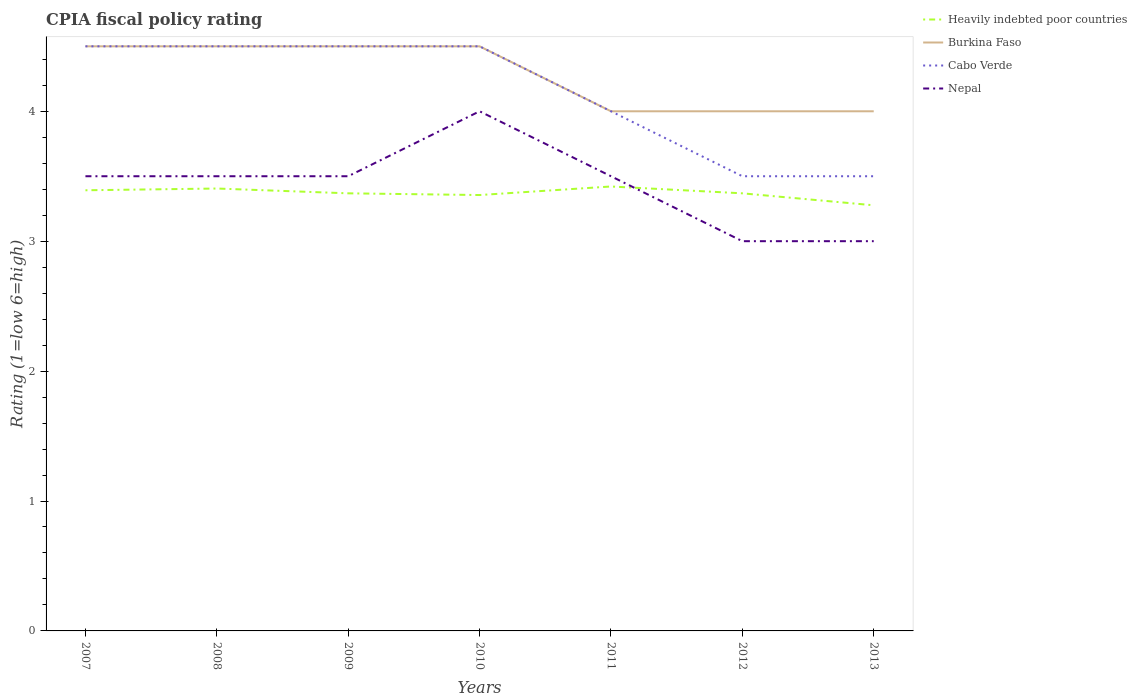How many different coloured lines are there?
Offer a terse response. 4. Does the line corresponding to Nepal intersect with the line corresponding to Burkina Faso?
Offer a terse response. No. What is the total CPIA rating in Heavily indebted poor countries in the graph?
Keep it short and to the point. -0.07. What is the difference between the highest and the second highest CPIA rating in Cabo Verde?
Your response must be concise. 1. What is the difference between the highest and the lowest CPIA rating in Heavily indebted poor countries?
Offer a very short reply. 3. How many legend labels are there?
Ensure brevity in your answer.  4. What is the title of the graph?
Ensure brevity in your answer.  CPIA fiscal policy rating. What is the label or title of the X-axis?
Offer a very short reply. Years. What is the Rating (1=low 6=high) in Heavily indebted poor countries in 2007?
Your answer should be very brief. 3.39. What is the Rating (1=low 6=high) in Burkina Faso in 2007?
Your response must be concise. 4.5. What is the Rating (1=low 6=high) of Heavily indebted poor countries in 2008?
Your response must be concise. 3.41. What is the Rating (1=low 6=high) of Burkina Faso in 2008?
Make the answer very short. 4.5. What is the Rating (1=low 6=high) in Heavily indebted poor countries in 2009?
Make the answer very short. 3.37. What is the Rating (1=low 6=high) of Cabo Verde in 2009?
Your answer should be compact. 4.5. What is the Rating (1=low 6=high) of Heavily indebted poor countries in 2010?
Your answer should be compact. 3.36. What is the Rating (1=low 6=high) in Heavily indebted poor countries in 2011?
Offer a very short reply. 3.42. What is the Rating (1=low 6=high) in Heavily indebted poor countries in 2012?
Provide a short and direct response. 3.37. What is the Rating (1=low 6=high) in Burkina Faso in 2012?
Your answer should be compact. 4. What is the Rating (1=low 6=high) in Cabo Verde in 2012?
Your answer should be very brief. 3.5. What is the Rating (1=low 6=high) of Heavily indebted poor countries in 2013?
Make the answer very short. 3.28. Across all years, what is the maximum Rating (1=low 6=high) of Heavily indebted poor countries?
Offer a terse response. 3.42. Across all years, what is the maximum Rating (1=low 6=high) in Burkina Faso?
Offer a terse response. 4.5. Across all years, what is the minimum Rating (1=low 6=high) in Heavily indebted poor countries?
Your answer should be compact. 3.28. Across all years, what is the minimum Rating (1=low 6=high) in Nepal?
Offer a very short reply. 3. What is the total Rating (1=low 6=high) of Heavily indebted poor countries in the graph?
Make the answer very short. 23.59. What is the total Rating (1=low 6=high) in Burkina Faso in the graph?
Give a very brief answer. 30. What is the total Rating (1=low 6=high) of Cabo Verde in the graph?
Offer a terse response. 29. What is the total Rating (1=low 6=high) of Nepal in the graph?
Ensure brevity in your answer.  24. What is the difference between the Rating (1=low 6=high) of Heavily indebted poor countries in 2007 and that in 2008?
Ensure brevity in your answer.  -0.01. What is the difference between the Rating (1=low 6=high) in Burkina Faso in 2007 and that in 2008?
Ensure brevity in your answer.  0. What is the difference between the Rating (1=low 6=high) in Cabo Verde in 2007 and that in 2008?
Give a very brief answer. 0. What is the difference between the Rating (1=low 6=high) in Heavily indebted poor countries in 2007 and that in 2009?
Ensure brevity in your answer.  0.02. What is the difference between the Rating (1=low 6=high) in Cabo Verde in 2007 and that in 2009?
Keep it short and to the point. 0. What is the difference between the Rating (1=low 6=high) of Heavily indebted poor countries in 2007 and that in 2010?
Give a very brief answer. 0.04. What is the difference between the Rating (1=low 6=high) in Cabo Verde in 2007 and that in 2010?
Keep it short and to the point. 0. What is the difference between the Rating (1=low 6=high) in Nepal in 2007 and that in 2010?
Your answer should be very brief. -0.5. What is the difference between the Rating (1=low 6=high) of Heavily indebted poor countries in 2007 and that in 2011?
Keep it short and to the point. -0.03. What is the difference between the Rating (1=low 6=high) in Nepal in 2007 and that in 2011?
Your answer should be very brief. 0. What is the difference between the Rating (1=low 6=high) of Heavily indebted poor countries in 2007 and that in 2012?
Your answer should be compact. 0.02. What is the difference between the Rating (1=low 6=high) in Burkina Faso in 2007 and that in 2012?
Offer a very short reply. 0.5. What is the difference between the Rating (1=low 6=high) in Heavily indebted poor countries in 2007 and that in 2013?
Provide a succinct answer. 0.12. What is the difference between the Rating (1=low 6=high) of Cabo Verde in 2007 and that in 2013?
Your response must be concise. 1. What is the difference between the Rating (1=low 6=high) of Nepal in 2007 and that in 2013?
Your response must be concise. 0.5. What is the difference between the Rating (1=low 6=high) of Heavily indebted poor countries in 2008 and that in 2009?
Your answer should be compact. 0.04. What is the difference between the Rating (1=low 6=high) in Cabo Verde in 2008 and that in 2009?
Your answer should be compact. 0. What is the difference between the Rating (1=low 6=high) of Nepal in 2008 and that in 2009?
Your answer should be compact. 0. What is the difference between the Rating (1=low 6=high) in Heavily indebted poor countries in 2008 and that in 2010?
Offer a terse response. 0.05. What is the difference between the Rating (1=low 6=high) in Burkina Faso in 2008 and that in 2010?
Offer a very short reply. 0. What is the difference between the Rating (1=low 6=high) in Nepal in 2008 and that in 2010?
Offer a very short reply. -0.5. What is the difference between the Rating (1=low 6=high) in Heavily indebted poor countries in 2008 and that in 2011?
Provide a succinct answer. -0.02. What is the difference between the Rating (1=low 6=high) in Burkina Faso in 2008 and that in 2011?
Offer a very short reply. 0.5. What is the difference between the Rating (1=low 6=high) of Heavily indebted poor countries in 2008 and that in 2012?
Your answer should be very brief. 0.04. What is the difference between the Rating (1=low 6=high) of Heavily indebted poor countries in 2008 and that in 2013?
Your answer should be very brief. 0.13. What is the difference between the Rating (1=low 6=high) of Cabo Verde in 2008 and that in 2013?
Offer a terse response. 1. What is the difference between the Rating (1=low 6=high) of Nepal in 2008 and that in 2013?
Offer a terse response. 0.5. What is the difference between the Rating (1=low 6=high) of Heavily indebted poor countries in 2009 and that in 2010?
Ensure brevity in your answer.  0.01. What is the difference between the Rating (1=low 6=high) in Cabo Verde in 2009 and that in 2010?
Make the answer very short. 0. What is the difference between the Rating (1=low 6=high) in Heavily indebted poor countries in 2009 and that in 2011?
Give a very brief answer. -0.05. What is the difference between the Rating (1=low 6=high) of Burkina Faso in 2009 and that in 2011?
Provide a succinct answer. 0.5. What is the difference between the Rating (1=low 6=high) in Burkina Faso in 2009 and that in 2012?
Your answer should be compact. 0.5. What is the difference between the Rating (1=low 6=high) of Cabo Verde in 2009 and that in 2012?
Provide a short and direct response. 1. What is the difference between the Rating (1=low 6=high) in Nepal in 2009 and that in 2012?
Make the answer very short. 0.5. What is the difference between the Rating (1=low 6=high) in Heavily indebted poor countries in 2009 and that in 2013?
Offer a very short reply. 0.09. What is the difference between the Rating (1=low 6=high) of Nepal in 2009 and that in 2013?
Give a very brief answer. 0.5. What is the difference between the Rating (1=low 6=high) of Heavily indebted poor countries in 2010 and that in 2011?
Keep it short and to the point. -0.07. What is the difference between the Rating (1=low 6=high) in Burkina Faso in 2010 and that in 2011?
Provide a short and direct response. 0.5. What is the difference between the Rating (1=low 6=high) in Nepal in 2010 and that in 2011?
Your answer should be very brief. 0.5. What is the difference between the Rating (1=low 6=high) in Heavily indebted poor countries in 2010 and that in 2012?
Make the answer very short. -0.01. What is the difference between the Rating (1=low 6=high) of Nepal in 2010 and that in 2012?
Keep it short and to the point. 1. What is the difference between the Rating (1=low 6=high) of Heavily indebted poor countries in 2010 and that in 2013?
Make the answer very short. 0.08. What is the difference between the Rating (1=low 6=high) of Nepal in 2010 and that in 2013?
Provide a short and direct response. 1. What is the difference between the Rating (1=low 6=high) of Heavily indebted poor countries in 2011 and that in 2012?
Your answer should be very brief. 0.05. What is the difference between the Rating (1=low 6=high) in Nepal in 2011 and that in 2012?
Provide a short and direct response. 0.5. What is the difference between the Rating (1=low 6=high) in Heavily indebted poor countries in 2011 and that in 2013?
Your response must be concise. 0.14. What is the difference between the Rating (1=low 6=high) of Burkina Faso in 2011 and that in 2013?
Make the answer very short. 0. What is the difference between the Rating (1=low 6=high) of Cabo Verde in 2011 and that in 2013?
Offer a terse response. 0.5. What is the difference between the Rating (1=low 6=high) in Nepal in 2011 and that in 2013?
Ensure brevity in your answer.  0.5. What is the difference between the Rating (1=low 6=high) of Heavily indebted poor countries in 2012 and that in 2013?
Offer a terse response. 0.09. What is the difference between the Rating (1=low 6=high) in Burkina Faso in 2012 and that in 2013?
Offer a terse response. 0. What is the difference between the Rating (1=low 6=high) in Cabo Verde in 2012 and that in 2013?
Give a very brief answer. 0. What is the difference between the Rating (1=low 6=high) in Nepal in 2012 and that in 2013?
Make the answer very short. 0. What is the difference between the Rating (1=low 6=high) of Heavily indebted poor countries in 2007 and the Rating (1=low 6=high) of Burkina Faso in 2008?
Offer a terse response. -1.11. What is the difference between the Rating (1=low 6=high) of Heavily indebted poor countries in 2007 and the Rating (1=low 6=high) of Cabo Verde in 2008?
Your answer should be compact. -1.11. What is the difference between the Rating (1=low 6=high) in Heavily indebted poor countries in 2007 and the Rating (1=low 6=high) in Nepal in 2008?
Provide a short and direct response. -0.11. What is the difference between the Rating (1=low 6=high) of Heavily indebted poor countries in 2007 and the Rating (1=low 6=high) of Burkina Faso in 2009?
Keep it short and to the point. -1.11. What is the difference between the Rating (1=low 6=high) in Heavily indebted poor countries in 2007 and the Rating (1=low 6=high) in Cabo Verde in 2009?
Provide a short and direct response. -1.11. What is the difference between the Rating (1=low 6=high) of Heavily indebted poor countries in 2007 and the Rating (1=low 6=high) of Nepal in 2009?
Keep it short and to the point. -0.11. What is the difference between the Rating (1=low 6=high) of Cabo Verde in 2007 and the Rating (1=low 6=high) of Nepal in 2009?
Your answer should be compact. 1. What is the difference between the Rating (1=low 6=high) of Heavily indebted poor countries in 2007 and the Rating (1=low 6=high) of Burkina Faso in 2010?
Give a very brief answer. -1.11. What is the difference between the Rating (1=low 6=high) in Heavily indebted poor countries in 2007 and the Rating (1=low 6=high) in Cabo Verde in 2010?
Keep it short and to the point. -1.11. What is the difference between the Rating (1=low 6=high) of Heavily indebted poor countries in 2007 and the Rating (1=low 6=high) of Nepal in 2010?
Give a very brief answer. -0.61. What is the difference between the Rating (1=low 6=high) in Burkina Faso in 2007 and the Rating (1=low 6=high) in Nepal in 2010?
Your response must be concise. 0.5. What is the difference between the Rating (1=low 6=high) of Cabo Verde in 2007 and the Rating (1=low 6=high) of Nepal in 2010?
Keep it short and to the point. 0.5. What is the difference between the Rating (1=low 6=high) in Heavily indebted poor countries in 2007 and the Rating (1=low 6=high) in Burkina Faso in 2011?
Offer a terse response. -0.61. What is the difference between the Rating (1=low 6=high) of Heavily indebted poor countries in 2007 and the Rating (1=low 6=high) of Cabo Verde in 2011?
Offer a very short reply. -0.61. What is the difference between the Rating (1=low 6=high) of Heavily indebted poor countries in 2007 and the Rating (1=low 6=high) of Nepal in 2011?
Offer a very short reply. -0.11. What is the difference between the Rating (1=low 6=high) of Heavily indebted poor countries in 2007 and the Rating (1=low 6=high) of Burkina Faso in 2012?
Offer a terse response. -0.61. What is the difference between the Rating (1=low 6=high) of Heavily indebted poor countries in 2007 and the Rating (1=low 6=high) of Cabo Verde in 2012?
Keep it short and to the point. -0.11. What is the difference between the Rating (1=low 6=high) in Heavily indebted poor countries in 2007 and the Rating (1=low 6=high) in Nepal in 2012?
Keep it short and to the point. 0.39. What is the difference between the Rating (1=low 6=high) in Burkina Faso in 2007 and the Rating (1=low 6=high) in Cabo Verde in 2012?
Your answer should be very brief. 1. What is the difference between the Rating (1=low 6=high) of Heavily indebted poor countries in 2007 and the Rating (1=low 6=high) of Burkina Faso in 2013?
Provide a short and direct response. -0.61. What is the difference between the Rating (1=low 6=high) of Heavily indebted poor countries in 2007 and the Rating (1=low 6=high) of Cabo Verde in 2013?
Provide a short and direct response. -0.11. What is the difference between the Rating (1=low 6=high) of Heavily indebted poor countries in 2007 and the Rating (1=low 6=high) of Nepal in 2013?
Give a very brief answer. 0.39. What is the difference between the Rating (1=low 6=high) in Burkina Faso in 2007 and the Rating (1=low 6=high) in Cabo Verde in 2013?
Provide a succinct answer. 1. What is the difference between the Rating (1=low 6=high) in Cabo Verde in 2007 and the Rating (1=low 6=high) in Nepal in 2013?
Ensure brevity in your answer.  1.5. What is the difference between the Rating (1=low 6=high) of Heavily indebted poor countries in 2008 and the Rating (1=low 6=high) of Burkina Faso in 2009?
Keep it short and to the point. -1.09. What is the difference between the Rating (1=low 6=high) of Heavily indebted poor countries in 2008 and the Rating (1=low 6=high) of Cabo Verde in 2009?
Make the answer very short. -1.09. What is the difference between the Rating (1=low 6=high) of Heavily indebted poor countries in 2008 and the Rating (1=low 6=high) of Nepal in 2009?
Keep it short and to the point. -0.09. What is the difference between the Rating (1=low 6=high) of Burkina Faso in 2008 and the Rating (1=low 6=high) of Nepal in 2009?
Ensure brevity in your answer.  1. What is the difference between the Rating (1=low 6=high) in Cabo Verde in 2008 and the Rating (1=low 6=high) in Nepal in 2009?
Give a very brief answer. 1. What is the difference between the Rating (1=low 6=high) of Heavily indebted poor countries in 2008 and the Rating (1=low 6=high) of Burkina Faso in 2010?
Provide a short and direct response. -1.09. What is the difference between the Rating (1=low 6=high) of Heavily indebted poor countries in 2008 and the Rating (1=low 6=high) of Cabo Verde in 2010?
Ensure brevity in your answer.  -1.09. What is the difference between the Rating (1=low 6=high) in Heavily indebted poor countries in 2008 and the Rating (1=low 6=high) in Nepal in 2010?
Provide a succinct answer. -0.59. What is the difference between the Rating (1=low 6=high) in Burkina Faso in 2008 and the Rating (1=low 6=high) in Cabo Verde in 2010?
Your answer should be compact. 0. What is the difference between the Rating (1=low 6=high) of Cabo Verde in 2008 and the Rating (1=low 6=high) of Nepal in 2010?
Keep it short and to the point. 0.5. What is the difference between the Rating (1=low 6=high) in Heavily indebted poor countries in 2008 and the Rating (1=low 6=high) in Burkina Faso in 2011?
Your answer should be compact. -0.59. What is the difference between the Rating (1=low 6=high) of Heavily indebted poor countries in 2008 and the Rating (1=low 6=high) of Cabo Verde in 2011?
Keep it short and to the point. -0.59. What is the difference between the Rating (1=low 6=high) in Heavily indebted poor countries in 2008 and the Rating (1=low 6=high) in Nepal in 2011?
Offer a very short reply. -0.09. What is the difference between the Rating (1=low 6=high) of Burkina Faso in 2008 and the Rating (1=low 6=high) of Cabo Verde in 2011?
Give a very brief answer. 0.5. What is the difference between the Rating (1=low 6=high) of Cabo Verde in 2008 and the Rating (1=low 6=high) of Nepal in 2011?
Offer a very short reply. 1. What is the difference between the Rating (1=low 6=high) in Heavily indebted poor countries in 2008 and the Rating (1=low 6=high) in Burkina Faso in 2012?
Make the answer very short. -0.59. What is the difference between the Rating (1=low 6=high) in Heavily indebted poor countries in 2008 and the Rating (1=low 6=high) in Cabo Verde in 2012?
Provide a succinct answer. -0.09. What is the difference between the Rating (1=low 6=high) of Heavily indebted poor countries in 2008 and the Rating (1=low 6=high) of Nepal in 2012?
Provide a succinct answer. 0.41. What is the difference between the Rating (1=low 6=high) of Heavily indebted poor countries in 2008 and the Rating (1=low 6=high) of Burkina Faso in 2013?
Your answer should be compact. -0.59. What is the difference between the Rating (1=low 6=high) in Heavily indebted poor countries in 2008 and the Rating (1=low 6=high) in Cabo Verde in 2013?
Give a very brief answer. -0.09. What is the difference between the Rating (1=low 6=high) of Heavily indebted poor countries in 2008 and the Rating (1=low 6=high) of Nepal in 2013?
Your answer should be very brief. 0.41. What is the difference between the Rating (1=low 6=high) of Burkina Faso in 2008 and the Rating (1=low 6=high) of Cabo Verde in 2013?
Ensure brevity in your answer.  1. What is the difference between the Rating (1=low 6=high) of Heavily indebted poor countries in 2009 and the Rating (1=low 6=high) of Burkina Faso in 2010?
Offer a very short reply. -1.13. What is the difference between the Rating (1=low 6=high) of Heavily indebted poor countries in 2009 and the Rating (1=low 6=high) of Cabo Verde in 2010?
Make the answer very short. -1.13. What is the difference between the Rating (1=low 6=high) in Heavily indebted poor countries in 2009 and the Rating (1=low 6=high) in Nepal in 2010?
Keep it short and to the point. -0.63. What is the difference between the Rating (1=low 6=high) in Burkina Faso in 2009 and the Rating (1=low 6=high) in Cabo Verde in 2010?
Offer a terse response. 0. What is the difference between the Rating (1=low 6=high) in Burkina Faso in 2009 and the Rating (1=low 6=high) in Nepal in 2010?
Provide a succinct answer. 0.5. What is the difference between the Rating (1=low 6=high) of Heavily indebted poor countries in 2009 and the Rating (1=low 6=high) of Burkina Faso in 2011?
Make the answer very short. -0.63. What is the difference between the Rating (1=low 6=high) in Heavily indebted poor countries in 2009 and the Rating (1=low 6=high) in Cabo Verde in 2011?
Your response must be concise. -0.63. What is the difference between the Rating (1=low 6=high) in Heavily indebted poor countries in 2009 and the Rating (1=low 6=high) in Nepal in 2011?
Make the answer very short. -0.13. What is the difference between the Rating (1=low 6=high) of Cabo Verde in 2009 and the Rating (1=low 6=high) of Nepal in 2011?
Keep it short and to the point. 1. What is the difference between the Rating (1=low 6=high) in Heavily indebted poor countries in 2009 and the Rating (1=low 6=high) in Burkina Faso in 2012?
Provide a succinct answer. -0.63. What is the difference between the Rating (1=low 6=high) of Heavily indebted poor countries in 2009 and the Rating (1=low 6=high) of Cabo Verde in 2012?
Ensure brevity in your answer.  -0.13. What is the difference between the Rating (1=low 6=high) in Heavily indebted poor countries in 2009 and the Rating (1=low 6=high) in Nepal in 2012?
Give a very brief answer. 0.37. What is the difference between the Rating (1=low 6=high) of Burkina Faso in 2009 and the Rating (1=low 6=high) of Cabo Verde in 2012?
Keep it short and to the point. 1. What is the difference between the Rating (1=low 6=high) in Burkina Faso in 2009 and the Rating (1=low 6=high) in Nepal in 2012?
Ensure brevity in your answer.  1.5. What is the difference between the Rating (1=low 6=high) in Cabo Verde in 2009 and the Rating (1=low 6=high) in Nepal in 2012?
Keep it short and to the point. 1.5. What is the difference between the Rating (1=low 6=high) of Heavily indebted poor countries in 2009 and the Rating (1=low 6=high) of Burkina Faso in 2013?
Offer a terse response. -0.63. What is the difference between the Rating (1=low 6=high) of Heavily indebted poor countries in 2009 and the Rating (1=low 6=high) of Cabo Verde in 2013?
Make the answer very short. -0.13. What is the difference between the Rating (1=low 6=high) in Heavily indebted poor countries in 2009 and the Rating (1=low 6=high) in Nepal in 2013?
Provide a short and direct response. 0.37. What is the difference between the Rating (1=low 6=high) of Burkina Faso in 2009 and the Rating (1=low 6=high) of Nepal in 2013?
Ensure brevity in your answer.  1.5. What is the difference between the Rating (1=low 6=high) in Cabo Verde in 2009 and the Rating (1=low 6=high) in Nepal in 2013?
Your answer should be compact. 1.5. What is the difference between the Rating (1=low 6=high) of Heavily indebted poor countries in 2010 and the Rating (1=low 6=high) of Burkina Faso in 2011?
Make the answer very short. -0.64. What is the difference between the Rating (1=low 6=high) of Heavily indebted poor countries in 2010 and the Rating (1=low 6=high) of Cabo Verde in 2011?
Keep it short and to the point. -0.64. What is the difference between the Rating (1=low 6=high) in Heavily indebted poor countries in 2010 and the Rating (1=low 6=high) in Nepal in 2011?
Keep it short and to the point. -0.14. What is the difference between the Rating (1=low 6=high) of Burkina Faso in 2010 and the Rating (1=low 6=high) of Nepal in 2011?
Ensure brevity in your answer.  1. What is the difference between the Rating (1=low 6=high) in Cabo Verde in 2010 and the Rating (1=low 6=high) in Nepal in 2011?
Make the answer very short. 1. What is the difference between the Rating (1=low 6=high) in Heavily indebted poor countries in 2010 and the Rating (1=low 6=high) in Burkina Faso in 2012?
Your answer should be very brief. -0.64. What is the difference between the Rating (1=low 6=high) in Heavily indebted poor countries in 2010 and the Rating (1=low 6=high) in Cabo Verde in 2012?
Your answer should be compact. -0.14. What is the difference between the Rating (1=low 6=high) of Heavily indebted poor countries in 2010 and the Rating (1=low 6=high) of Nepal in 2012?
Your response must be concise. 0.36. What is the difference between the Rating (1=low 6=high) of Burkina Faso in 2010 and the Rating (1=low 6=high) of Nepal in 2012?
Your answer should be very brief. 1.5. What is the difference between the Rating (1=low 6=high) in Heavily indebted poor countries in 2010 and the Rating (1=low 6=high) in Burkina Faso in 2013?
Make the answer very short. -0.64. What is the difference between the Rating (1=low 6=high) of Heavily indebted poor countries in 2010 and the Rating (1=low 6=high) of Cabo Verde in 2013?
Give a very brief answer. -0.14. What is the difference between the Rating (1=low 6=high) in Heavily indebted poor countries in 2010 and the Rating (1=low 6=high) in Nepal in 2013?
Keep it short and to the point. 0.36. What is the difference between the Rating (1=low 6=high) of Cabo Verde in 2010 and the Rating (1=low 6=high) of Nepal in 2013?
Your response must be concise. 1.5. What is the difference between the Rating (1=low 6=high) in Heavily indebted poor countries in 2011 and the Rating (1=low 6=high) in Burkina Faso in 2012?
Your answer should be compact. -0.58. What is the difference between the Rating (1=low 6=high) of Heavily indebted poor countries in 2011 and the Rating (1=low 6=high) of Cabo Verde in 2012?
Offer a very short reply. -0.08. What is the difference between the Rating (1=low 6=high) in Heavily indebted poor countries in 2011 and the Rating (1=low 6=high) in Nepal in 2012?
Offer a very short reply. 0.42. What is the difference between the Rating (1=low 6=high) in Burkina Faso in 2011 and the Rating (1=low 6=high) in Cabo Verde in 2012?
Your answer should be very brief. 0.5. What is the difference between the Rating (1=low 6=high) in Burkina Faso in 2011 and the Rating (1=low 6=high) in Nepal in 2012?
Keep it short and to the point. 1. What is the difference between the Rating (1=low 6=high) of Cabo Verde in 2011 and the Rating (1=low 6=high) of Nepal in 2012?
Ensure brevity in your answer.  1. What is the difference between the Rating (1=low 6=high) of Heavily indebted poor countries in 2011 and the Rating (1=low 6=high) of Burkina Faso in 2013?
Offer a very short reply. -0.58. What is the difference between the Rating (1=low 6=high) of Heavily indebted poor countries in 2011 and the Rating (1=low 6=high) of Cabo Verde in 2013?
Give a very brief answer. -0.08. What is the difference between the Rating (1=low 6=high) in Heavily indebted poor countries in 2011 and the Rating (1=low 6=high) in Nepal in 2013?
Keep it short and to the point. 0.42. What is the difference between the Rating (1=low 6=high) of Burkina Faso in 2011 and the Rating (1=low 6=high) of Nepal in 2013?
Offer a very short reply. 1. What is the difference between the Rating (1=low 6=high) of Cabo Verde in 2011 and the Rating (1=low 6=high) of Nepal in 2013?
Keep it short and to the point. 1. What is the difference between the Rating (1=low 6=high) in Heavily indebted poor countries in 2012 and the Rating (1=low 6=high) in Burkina Faso in 2013?
Give a very brief answer. -0.63. What is the difference between the Rating (1=low 6=high) of Heavily indebted poor countries in 2012 and the Rating (1=low 6=high) of Cabo Verde in 2013?
Provide a short and direct response. -0.13. What is the difference between the Rating (1=low 6=high) in Heavily indebted poor countries in 2012 and the Rating (1=low 6=high) in Nepal in 2013?
Ensure brevity in your answer.  0.37. What is the average Rating (1=low 6=high) in Heavily indebted poor countries per year?
Offer a very short reply. 3.37. What is the average Rating (1=low 6=high) of Burkina Faso per year?
Offer a very short reply. 4.29. What is the average Rating (1=low 6=high) in Cabo Verde per year?
Your answer should be very brief. 4.14. What is the average Rating (1=low 6=high) of Nepal per year?
Give a very brief answer. 3.43. In the year 2007, what is the difference between the Rating (1=low 6=high) in Heavily indebted poor countries and Rating (1=low 6=high) in Burkina Faso?
Give a very brief answer. -1.11. In the year 2007, what is the difference between the Rating (1=low 6=high) in Heavily indebted poor countries and Rating (1=low 6=high) in Cabo Verde?
Give a very brief answer. -1.11. In the year 2007, what is the difference between the Rating (1=low 6=high) in Heavily indebted poor countries and Rating (1=low 6=high) in Nepal?
Offer a terse response. -0.11. In the year 2007, what is the difference between the Rating (1=low 6=high) in Cabo Verde and Rating (1=low 6=high) in Nepal?
Your answer should be compact. 1. In the year 2008, what is the difference between the Rating (1=low 6=high) in Heavily indebted poor countries and Rating (1=low 6=high) in Burkina Faso?
Your answer should be compact. -1.09. In the year 2008, what is the difference between the Rating (1=low 6=high) of Heavily indebted poor countries and Rating (1=low 6=high) of Cabo Verde?
Your answer should be compact. -1.09. In the year 2008, what is the difference between the Rating (1=low 6=high) in Heavily indebted poor countries and Rating (1=low 6=high) in Nepal?
Provide a short and direct response. -0.09. In the year 2008, what is the difference between the Rating (1=low 6=high) of Burkina Faso and Rating (1=low 6=high) of Cabo Verde?
Give a very brief answer. 0. In the year 2009, what is the difference between the Rating (1=low 6=high) of Heavily indebted poor countries and Rating (1=low 6=high) of Burkina Faso?
Ensure brevity in your answer.  -1.13. In the year 2009, what is the difference between the Rating (1=low 6=high) of Heavily indebted poor countries and Rating (1=low 6=high) of Cabo Verde?
Offer a very short reply. -1.13. In the year 2009, what is the difference between the Rating (1=low 6=high) in Heavily indebted poor countries and Rating (1=low 6=high) in Nepal?
Give a very brief answer. -0.13. In the year 2009, what is the difference between the Rating (1=low 6=high) in Burkina Faso and Rating (1=low 6=high) in Cabo Verde?
Give a very brief answer. 0. In the year 2009, what is the difference between the Rating (1=low 6=high) of Burkina Faso and Rating (1=low 6=high) of Nepal?
Provide a succinct answer. 1. In the year 2010, what is the difference between the Rating (1=low 6=high) in Heavily indebted poor countries and Rating (1=low 6=high) in Burkina Faso?
Your answer should be compact. -1.14. In the year 2010, what is the difference between the Rating (1=low 6=high) in Heavily indebted poor countries and Rating (1=low 6=high) in Cabo Verde?
Keep it short and to the point. -1.14. In the year 2010, what is the difference between the Rating (1=low 6=high) of Heavily indebted poor countries and Rating (1=low 6=high) of Nepal?
Offer a terse response. -0.64. In the year 2010, what is the difference between the Rating (1=low 6=high) in Burkina Faso and Rating (1=low 6=high) in Cabo Verde?
Your answer should be compact. 0. In the year 2010, what is the difference between the Rating (1=low 6=high) of Burkina Faso and Rating (1=low 6=high) of Nepal?
Offer a very short reply. 0.5. In the year 2011, what is the difference between the Rating (1=low 6=high) of Heavily indebted poor countries and Rating (1=low 6=high) of Burkina Faso?
Your answer should be compact. -0.58. In the year 2011, what is the difference between the Rating (1=low 6=high) of Heavily indebted poor countries and Rating (1=low 6=high) of Cabo Verde?
Ensure brevity in your answer.  -0.58. In the year 2011, what is the difference between the Rating (1=low 6=high) in Heavily indebted poor countries and Rating (1=low 6=high) in Nepal?
Provide a succinct answer. -0.08. In the year 2011, what is the difference between the Rating (1=low 6=high) of Burkina Faso and Rating (1=low 6=high) of Nepal?
Provide a short and direct response. 0.5. In the year 2011, what is the difference between the Rating (1=low 6=high) in Cabo Verde and Rating (1=low 6=high) in Nepal?
Provide a short and direct response. 0.5. In the year 2012, what is the difference between the Rating (1=low 6=high) in Heavily indebted poor countries and Rating (1=low 6=high) in Burkina Faso?
Your response must be concise. -0.63. In the year 2012, what is the difference between the Rating (1=low 6=high) of Heavily indebted poor countries and Rating (1=low 6=high) of Cabo Verde?
Offer a terse response. -0.13. In the year 2012, what is the difference between the Rating (1=low 6=high) of Heavily indebted poor countries and Rating (1=low 6=high) of Nepal?
Provide a succinct answer. 0.37. In the year 2012, what is the difference between the Rating (1=low 6=high) of Burkina Faso and Rating (1=low 6=high) of Cabo Verde?
Provide a succinct answer. 0.5. In the year 2012, what is the difference between the Rating (1=low 6=high) of Burkina Faso and Rating (1=low 6=high) of Nepal?
Your response must be concise. 1. In the year 2013, what is the difference between the Rating (1=low 6=high) in Heavily indebted poor countries and Rating (1=low 6=high) in Burkina Faso?
Provide a succinct answer. -0.72. In the year 2013, what is the difference between the Rating (1=low 6=high) in Heavily indebted poor countries and Rating (1=low 6=high) in Cabo Verde?
Ensure brevity in your answer.  -0.22. In the year 2013, what is the difference between the Rating (1=low 6=high) of Heavily indebted poor countries and Rating (1=low 6=high) of Nepal?
Offer a very short reply. 0.28. In the year 2013, what is the difference between the Rating (1=low 6=high) of Burkina Faso and Rating (1=low 6=high) of Nepal?
Provide a short and direct response. 1. In the year 2013, what is the difference between the Rating (1=low 6=high) of Cabo Verde and Rating (1=low 6=high) of Nepal?
Your answer should be very brief. 0.5. What is the ratio of the Rating (1=low 6=high) of Heavily indebted poor countries in 2007 to that in 2008?
Make the answer very short. 1. What is the ratio of the Rating (1=low 6=high) in Burkina Faso in 2007 to that in 2008?
Offer a terse response. 1. What is the ratio of the Rating (1=low 6=high) in Cabo Verde in 2007 to that in 2008?
Your response must be concise. 1. What is the ratio of the Rating (1=low 6=high) in Nepal in 2007 to that in 2008?
Provide a succinct answer. 1. What is the ratio of the Rating (1=low 6=high) in Heavily indebted poor countries in 2007 to that in 2009?
Offer a terse response. 1.01. What is the ratio of the Rating (1=low 6=high) in Cabo Verde in 2007 to that in 2009?
Offer a terse response. 1. What is the ratio of the Rating (1=low 6=high) of Heavily indebted poor countries in 2007 to that in 2010?
Your answer should be very brief. 1.01. What is the ratio of the Rating (1=low 6=high) in Cabo Verde in 2007 to that in 2010?
Provide a succinct answer. 1. What is the ratio of the Rating (1=low 6=high) of Burkina Faso in 2007 to that in 2011?
Offer a terse response. 1.12. What is the ratio of the Rating (1=low 6=high) in Heavily indebted poor countries in 2007 to that in 2013?
Provide a succinct answer. 1.04. What is the ratio of the Rating (1=low 6=high) of Burkina Faso in 2007 to that in 2013?
Offer a terse response. 1.12. What is the ratio of the Rating (1=low 6=high) of Cabo Verde in 2008 to that in 2009?
Offer a very short reply. 1. What is the ratio of the Rating (1=low 6=high) in Heavily indebted poor countries in 2008 to that in 2010?
Provide a succinct answer. 1.01. What is the ratio of the Rating (1=low 6=high) in Burkina Faso in 2008 to that in 2010?
Make the answer very short. 1. What is the ratio of the Rating (1=low 6=high) in Cabo Verde in 2008 to that in 2010?
Provide a succinct answer. 1. What is the ratio of the Rating (1=low 6=high) of Nepal in 2008 to that in 2010?
Your answer should be very brief. 0.88. What is the ratio of the Rating (1=low 6=high) in Burkina Faso in 2008 to that in 2011?
Your answer should be compact. 1.12. What is the ratio of the Rating (1=low 6=high) in Cabo Verde in 2008 to that in 2011?
Give a very brief answer. 1.12. What is the ratio of the Rating (1=low 6=high) of Heavily indebted poor countries in 2008 to that in 2012?
Provide a short and direct response. 1.01. What is the ratio of the Rating (1=low 6=high) of Burkina Faso in 2008 to that in 2012?
Provide a succinct answer. 1.12. What is the ratio of the Rating (1=low 6=high) in Cabo Verde in 2008 to that in 2012?
Your response must be concise. 1.29. What is the ratio of the Rating (1=low 6=high) of Heavily indebted poor countries in 2008 to that in 2013?
Keep it short and to the point. 1.04. What is the ratio of the Rating (1=low 6=high) in Burkina Faso in 2008 to that in 2013?
Offer a very short reply. 1.12. What is the ratio of the Rating (1=low 6=high) of Heavily indebted poor countries in 2009 to that in 2010?
Your answer should be compact. 1. What is the ratio of the Rating (1=low 6=high) in Heavily indebted poor countries in 2009 to that in 2011?
Your answer should be very brief. 0.98. What is the ratio of the Rating (1=low 6=high) in Nepal in 2009 to that in 2011?
Give a very brief answer. 1. What is the ratio of the Rating (1=low 6=high) in Heavily indebted poor countries in 2009 to that in 2012?
Provide a short and direct response. 1. What is the ratio of the Rating (1=low 6=high) in Cabo Verde in 2009 to that in 2012?
Give a very brief answer. 1.29. What is the ratio of the Rating (1=low 6=high) of Nepal in 2009 to that in 2012?
Your answer should be very brief. 1.17. What is the ratio of the Rating (1=low 6=high) in Heavily indebted poor countries in 2009 to that in 2013?
Make the answer very short. 1.03. What is the ratio of the Rating (1=low 6=high) of Cabo Verde in 2009 to that in 2013?
Provide a succinct answer. 1.29. What is the ratio of the Rating (1=low 6=high) of Heavily indebted poor countries in 2010 to that in 2011?
Offer a terse response. 0.98. What is the ratio of the Rating (1=low 6=high) of Heavily indebted poor countries in 2010 to that in 2012?
Give a very brief answer. 1. What is the ratio of the Rating (1=low 6=high) of Burkina Faso in 2010 to that in 2012?
Make the answer very short. 1.12. What is the ratio of the Rating (1=low 6=high) in Nepal in 2010 to that in 2012?
Your response must be concise. 1.33. What is the ratio of the Rating (1=low 6=high) of Heavily indebted poor countries in 2010 to that in 2013?
Offer a terse response. 1.02. What is the ratio of the Rating (1=low 6=high) in Heavily indebted poor countries in 2011 to that in 2012?
Your response must be concise. 1.02. What is the ratio of the Rating (1=low 6=high) in Cabo Verde in 2011 to that in 2012?
Your response must be concise. 1.14. What is the ratio of the Rating (1=low 6=high) of Heavily indebted poor countries in 2011 to that in 2013?
Ensure brevity in your answer.  1.04. What is the ratio of the Rating (1=low 6=high) of Cabo Verde in 2011 to that in 2013?
Provide a succinct answer. 1.14. What is the ratio of the Rating (1=low 6=high) in Heavily indebted poor countries in 2012 to that in 2013?
Ensure brevity in your answer.  1.03. What is the ratio of the Rating (1=low 6=high) in Cabo Verde in 2012 to that in 2013?
Keep it short and to the point. 1. What is the difference between the highest and the second highest Rating (1=low 6=high) in Heavily indebted poor countries?
Offer a very short reply. 0.02. What is the difference between the highest and the second highest Rating (1=low 6=high) in Cabo Verde?
Offer a terse response. 0. What is the difference between the highest and the lowest Rating (1=low 6=high) in Heavily indebted poor countries?
Offer a very short reply. 0.14. What is the difference between the highest and the lowest Rating (1=low 6=high) in Burkina Faso?
Offer a very short reply. 0.5. What is the difference between the highest and the lowest Rating (1=low 6=high) in Nepal?
Ensure brevity in your answer.  1. 